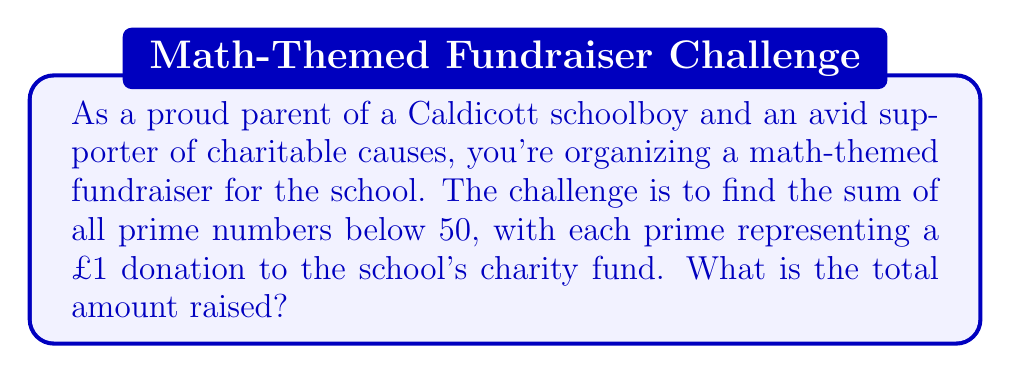Can you solve this math problem? Let's approach this step-by-step:

1) First, we need to identify all prime numbers below 50. A prime number is a natural number greater than 1 that is only divisible by 1 and itself.

2) The prime numbers below 50 are:
   2, 3, 5, 7, 11, 13, 17, 19, 23, 29, 31, 37, 41, 43, 47

3) Now, we need to sum these numbers:

   $$\sum_{p \text{ prime}, p < 50} p = 2 + 3 + 5 + 7 + 11 + 13 + 17 + 19 + 23 + 29 + 31 + 37 + 41 + 43 + 47$$

4) Calculating this sum:
   
   $$\begin{align}
   &2 + 3 + 5 + 7 + 11 + 13 + 17 + 19 + 23 + 29 + 31 + 37 + 41 + 43 + 47 \\
   &= (2 + 3 + 5 + 7) + (11 + 13 + 17 + 19) + (23 + 29 + 31 + 37) + (41 + 43 + 47) \\
   &= 17 + 60 + 120 + 131 \\
   &= 328
   \end{align}$$

5) Therefore, the sum of all prime numbers below 50 is 328.
Answer: The total amount raised for the school's charity fund is £328. 